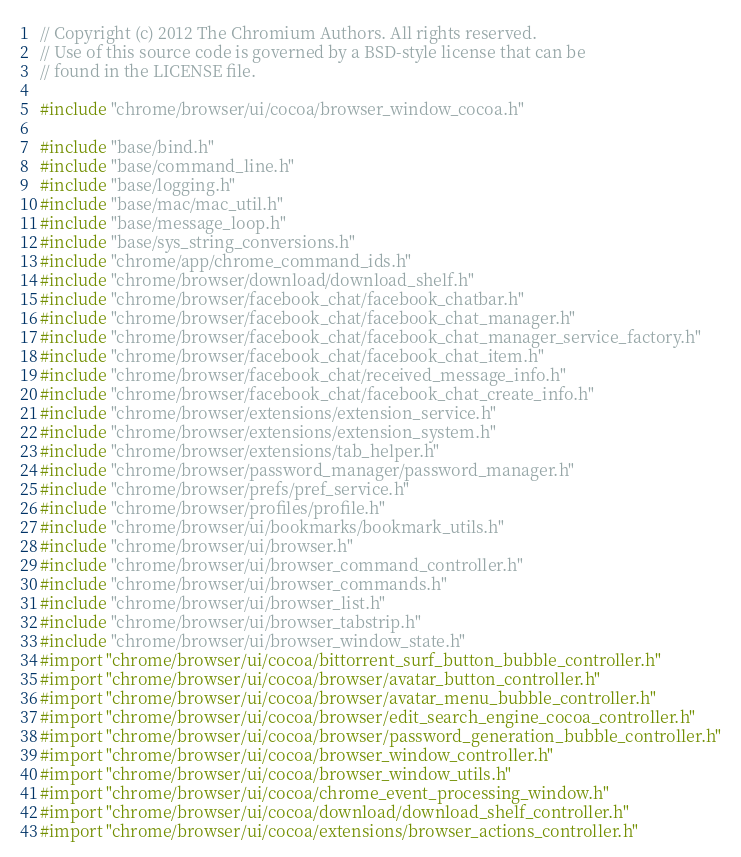Convert code to text. <code><loc_0><loc_0><loc_500><loc_500><_ObjectiveC_>// Copyright (c) 2012 The Chromium Authors. All rights reserved.
// Use of this source code is governed by a BSD-style license that can be
// found in the LICENSE file.

#include "chrome/browser/ui/cocoa/browser_window_cocoa.h"

#include "base/bind.h"
#include "base/command_line.h"
#include "base/logging.h"
#include "base/mac/mac_util.h"
#include "base/message_loop.h"
#include "base/sys_string_conversions.h"
#include "chrome/app/chrome_command_ids.h"
#include "chrome/browser/download/download_shelf.h"
#include "chrome/browser/facebook_chat/facebook_chatbar.h"
#include "chrome/browser/facebook_chat/facebook_chat_manager.h"
#include "chrome/browser/facebook_chat/facebook_chat_manager_service_factory.h"
#include "chrome/browser/facebook_chat/facebook_chat_item.h"
#include "chrome/browser/facebook_chat/received_message_info.h"
#include "chrome/browser/facebook_chat/facebook_chat_create_info.h"
#include "chrome/browser/extensions/extension_service.h"
#include "chrome/browser/extensions/extension_system.h"
#include "chrome/browser/extensions/tab_helper.h"
#include "chrome/browser/password_manager/password_manager.h"
#include "chrome/browser/prefs/pref_service.h"
#include "chrome/browser/profiles/profile.h"
#include "chrome/browser/ui/bookmarks/bookmark_utils.h"
#include "chrome/browser/ui/browser.h"
#include "chrome/browser/ui/browser_command_controller.h"
#include "chrome/browser/ui/browser_commands.h"
#include "chrome/browser/ui/browser_list.h"
#include "chrome/browser/ui/browser_tabstrip.h"
#include "chrome/browser/ui/browser_window_state.h"
#import "chrome/browser/ui/cocoa/bittorrent_surf_button_bubble_controller.h"
#import "chrome/browser/ui/cocoa/browser/avatar_button_controller.h"
#import "chrome/browser/ui/cocoa/browser/avatar_menu_bubble_controller.h"
#import "chrome/browser/ui/cocoa/browser/edit_search_engine_cocoa_controller.h"
#import "chrome/browser/ui/cocoa/browser/password_generation_bubble_controller.h"
#import "chrome/browser/ui/cocoa/browser_window_controller.h"
#import "chrome/browser/ui/cocoa/browser_window_utils.h"
#import "chrome/browser/ui/cocoa/chrome_event_processing_window.h"
#import "chrome/browser/ui/cocoa/download/download_shelf_controller.h"
#import "chrome/browser/ui/cocoa/extensions/browser_actions_controller.h"</code> 